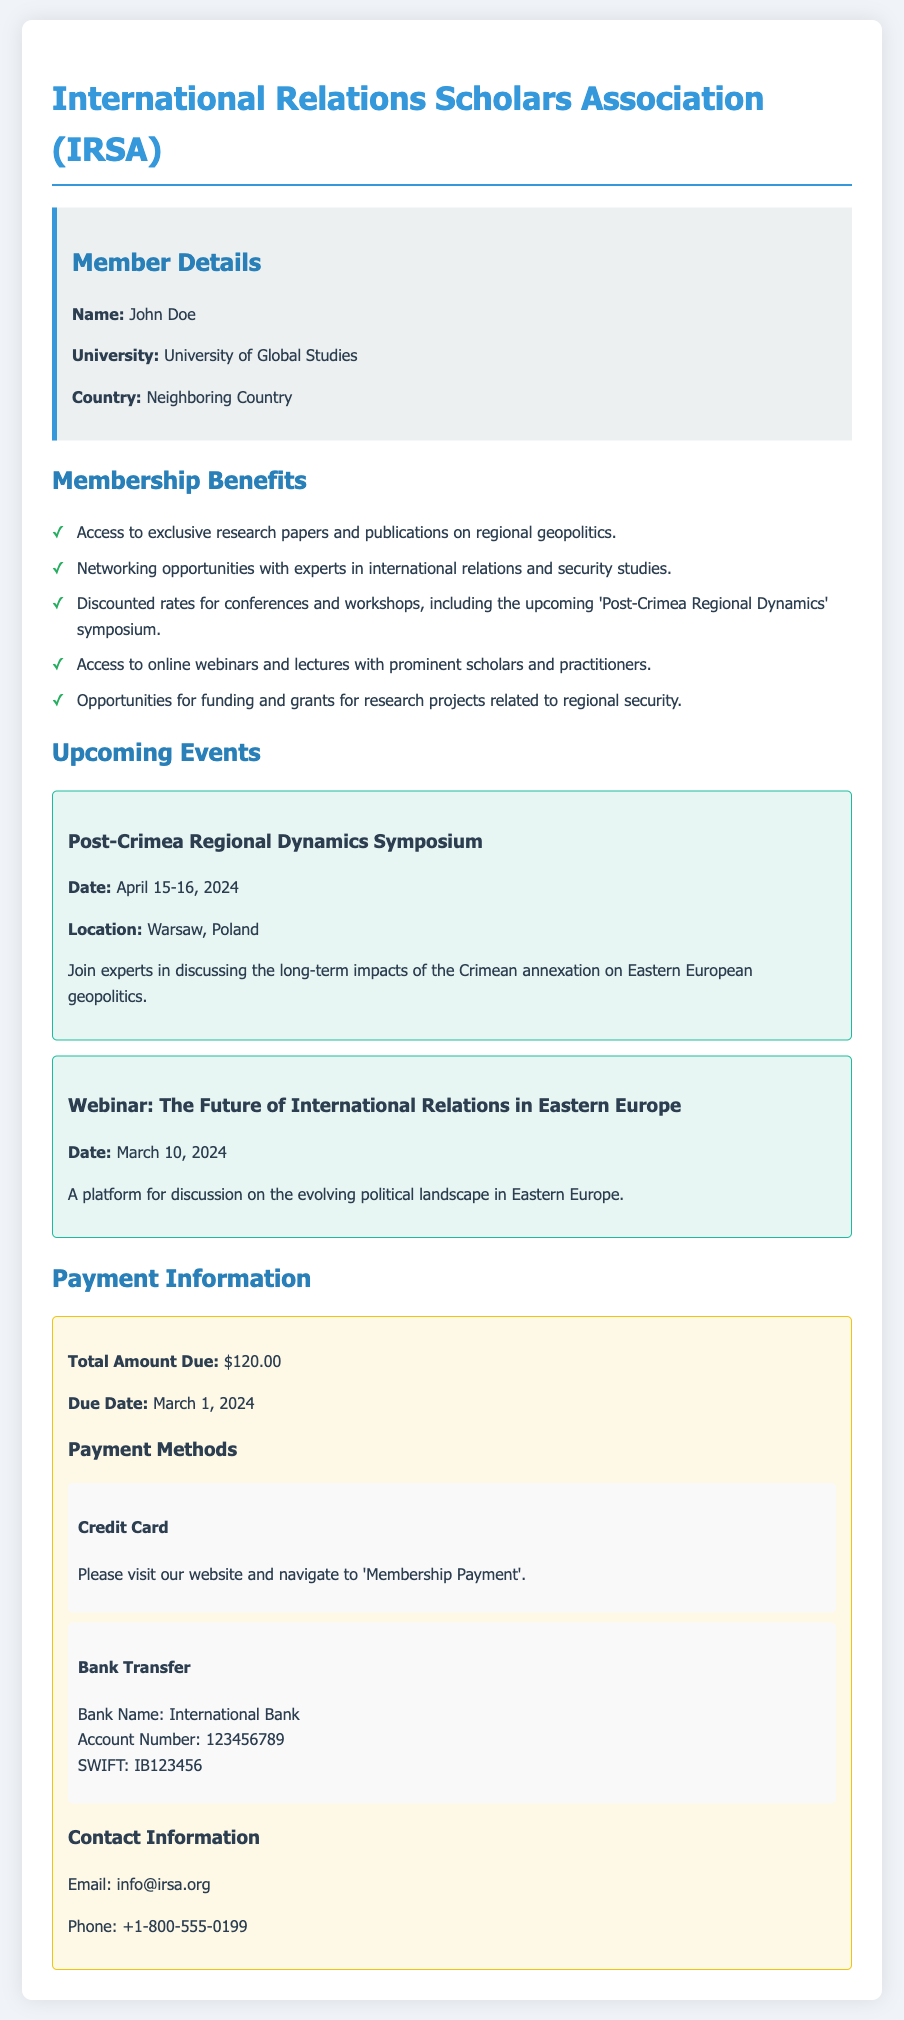What is the total amount due? The total amount due is specified in the payment information section of the document.
Answer: $120.00 When is the payment due? The due date for payment is found in the payment information section of the document.
Answer: March 1, 2024 What is the name of the upcoming symposium? The name of the upcoming symposium is listed under the upcoming events section of the document.
Answer: Post-Crimea Regional Dynamics Symposium Who should be contacted for more information? The contact information section provides email and phone details for inquiries.
Answer: info@irsa.org Where will the 'Post-Crimea Regional Dynamics' symposium be held? The location of the symposium is mentioned in the upcoming events section.
Answer: Warsaw, Poland What type of opportunities does membership provide related to research projects? The membership benefits section lists the specific opportunities available for members.
Answer: Funding and grants On what date is the webinar scheduled? The date of the webinar is specified in the upcoming events section of the document.
Answer: March 10, 2024 What payment method requires navigating to the website? The payment methods section specifies which payment method involves visiting the website.
Answer: Credit Card 